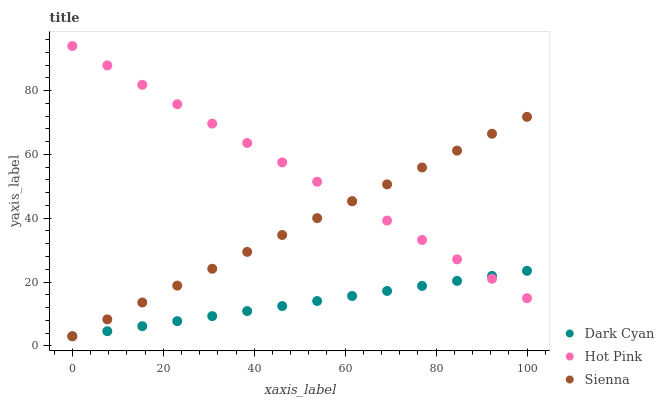Does Dark Cyan have the minimum area under the curve?
Answer yes or no. Yes. Does Hot Pink have the maximum area under the curve?
Answer yes or no. Yes. Does Sienna have the minimum area under the curve?
Answer yes or no. No. Does Sienna have the maximum area under the curve?
Answer yes or no. No. Is Dark Cyan the smoothest?
Answer yes or no. Yes. Is Hot Pink the roughest?
Answer yes or no. Yes. Is Sienna the smoothest?
Answer yes or no. No. Is Sienna the roughest?
Answer yes or no. No. Does Dark Cyan have the lowest value?
Answer yes or no. Yes. Does Hot Pink have the lowest value?
Answer yes or no. No. Does Hot Pink have the highest value?
Answer yes or no. Yes. Does Sienna have the highest value?
Answer yes or no. No. Does Sienna intersect Dark Cyan?
Answer yes or no. Yes. Is Sienna less than Dark Cyan?
Answer yes or no. No. Is Sienna greater than Dark Cyan?
Answer yes or no. No. 